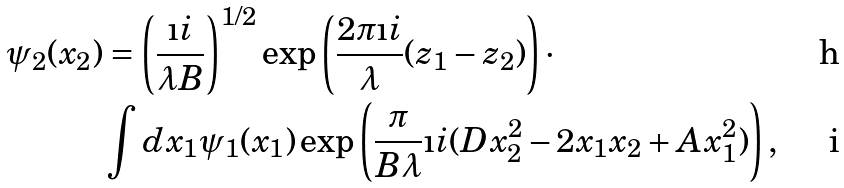<formula> <loc_0><loc_0><loc_500><loc_500>\psi _ { 2 } ( x _ { 2 } ) & = \left ( \frac { \i i } { \lambda B } \right ) ^ { 1 / 2 } \exp \left ( \frac { 2 \pi \i i } { \lambda } ( z _ { 1 } - z _ { 2 } ) \right ) \cdot \\ & \int d x _ { 1 } \psi _ { 1 } ( x _ { 1 } ) \exp \left ( \frac { \pi } { B \lambda } \i i ( D x _ { 2 } ^ { 2 } - 2 x _ { 1 } x _ { 2 } + A x _ { 1 } ^ { 2 } ) \right ) ,</formula> 